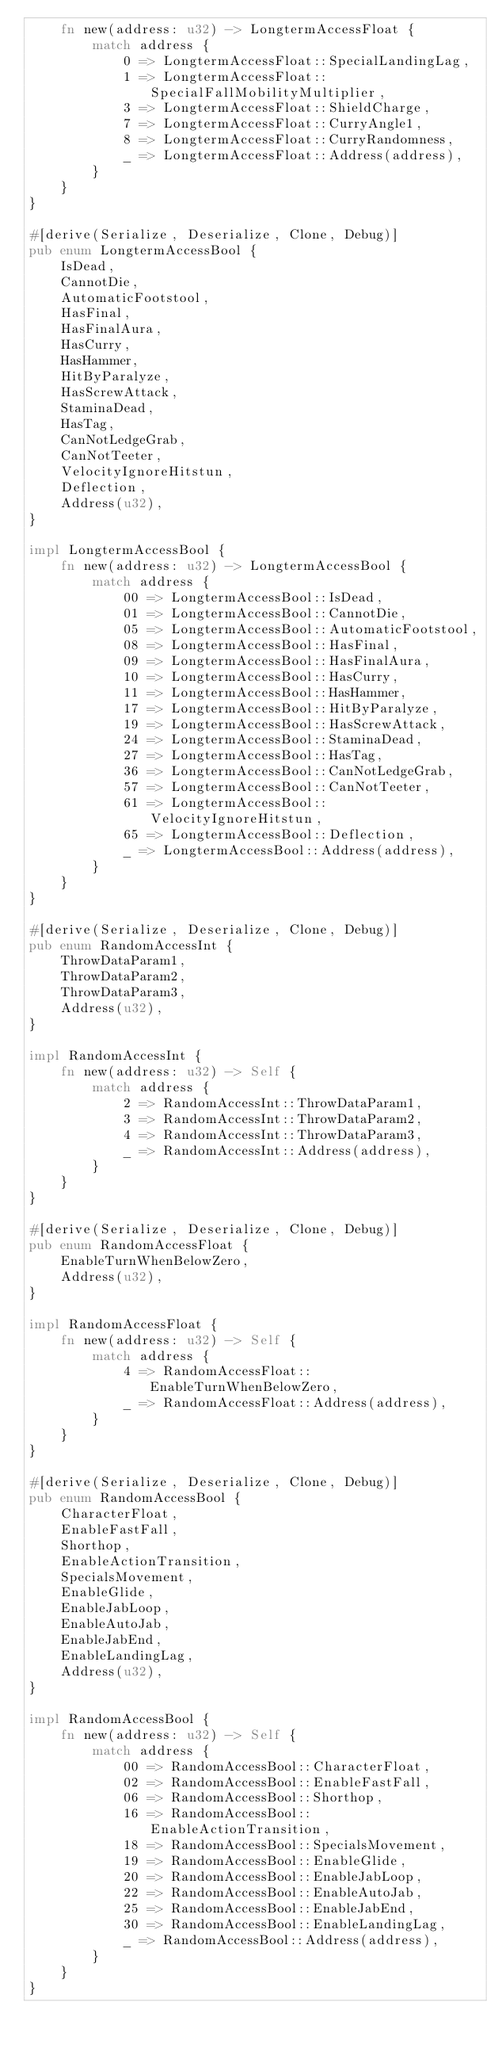Convert code to text. <code><loc_0><loc_0><loc_500><loc_500><_Rust_>    fn new(address: u32) -> LongtermAccessFloat {
        match address {
            0 => LongtermAccessFloat::SpecialLandingLag,
            1 => LongtermAccessFloat::SpecialFallMobilityMultiplier,
            3 => LongtermAccessFloat::ShieldCharge,
            7 => LongtermAccessFloat::CurryAngle1,
            8 => LongtermAccessFloat::CurryRandomness,
            _ => LongtermAccessFloat::Address(address),
        }
    }
}

#[derive(Serialize, Deserialize, Clone, Debug)]
pub enum LongtermAccessBool {
    IsDead,
    CannotDie,
    AutomaticFootstool,
    HasFinal,
    HasFinalAura,
    HasCurry,
    HasHammer,
    HitByParalyze,
    HasScrewAttack,
    StaminaDead,
    HasTag,
    CanNotLedgeGrab,
    CanNotTeeter,
    VelocityIgnoreHitstun,
    Deflection,
    Address(u32),
}

impl LongtermAccessBool {
    fn new(address: u32) -> LongtermAccessBool {
        match address {
            00 => LongtermAccessBool::IsDead,
            01 => LongtermAccessBool::CannotDie,
            05 => LongtermAccessBool::AutomaticFootstool,
            08 => LongtermAccessBool::HasFinal,
            09 => LongtermAccessBool::HasFinalAura,
            10 => LongtermAccessBool::HasCurry,
            11 => LongtermAccessBool::HasHammer,
            17 => LongtermAccessBool::HitByParalyze,
            19 => LongtermAccessBool::HasScrewAttack,
            24 => LongtermAccessBool::StaminaDead,
            27 => LongtermAccessBool::HasTag,
            36 => LongtermAccessBool::CanNotLedgeGrab,
            57 => LongtermAccessBool::CanNotTeeter,
            61 => LongtermAccessBool::VelocityIgnoreHitstun,
            65 => LongtermAccessBool::Deflection,
            _ => LongtermAccessBool::Address(address),
        }
    }
}

#[derive(Serialize, Deserialize, Clone, Debug)]
pub enum RandomAccessInt {
    ThrowDataParam1,
    ThrowDataParam2,
    ThrowDataParam3,
    Address(u32),
}

impl RandomAccessInt {
    fn new(address: u32) -> Self {
        match address {
            2 => RandomAccessInt::ThrowDataParam1,
            3 => RandomAccessInt::ThrowDataParam2,
            4 => RandomAccessInt::ThrowDataParam3,
            _ => RandomAccessInt::Address(address),
        }
    }
}

#[derive(Serialize, Deserialize, Clone, Debug)]
pub enum RandomAccessFloat {
    EnableTurnWhenBelowZero,
    Address(u32),
}

impl RandomAccessFloat {
    fn new(address: u32) -> Self {
        match address {
            4 => RandomAccessFloat::EnableTurnWhenBelowZero,
            _ => RandomAccessFloat::Address(address),
        }
    }
}

#[derive(Serialize, Deserialize, Clone, Debug)]
pub enum RandomAccessBool {
    CharacterFloat,
    EnableFastFall,
    Shorthop,
    EnableActionTransition,
    SpecialsMovement,
    EnableGlide,
    EnableJabLoop,
    EnableAutoJab,
    EnableJabEnd,
    EnableLandingLag,
    Address(u32),
}

impl RandomAccessBool {
    fn new(address: u32) -> Self {
        match address {
            00 => RandomAccessBool::CharacterFloat,
            02 => RandomAccessBool::EnableFastFall,
            06 => RandomAccessBool::Shorthop,
            16 => RandomAccessBool::EnableActionTransition,
            18 => RandomAccessBool::SpecialsMovement,
            19 => RandomAccessBool::EnableGlide,
            20 => RandomAccessBool::EnableJabLoop,
            22 => RandomAccessBool::EnableAutoJab,
            25 => RandomAccessBool::EnableJabEnd,
            30 => RandomAccessBool::EnableLandingLag,
            _ => RandomAccessBool::Address(address),
        }
    }
}
</code> 